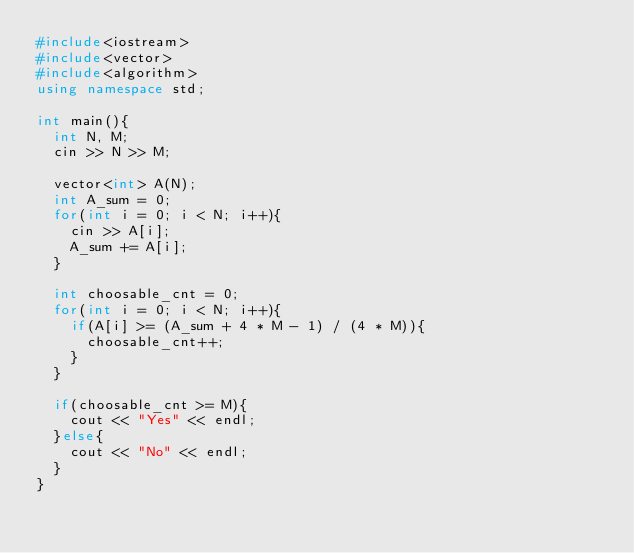<code> <loc_0><loc_0><loc_500><loc_500><_C++_>#include<iostream>
#include<vector>
#include<algorithm>
using namespace std;

int main(){
  int N, M;
  cin >> N >> M;

  vector<int> A(N);
  int A_sum = 0;
  for(int i = 0; i < N; i++){
    cin >> A[i];
    A_sum += A[i];
  }

  int choosable_cnt = 0;
  for(int i = 0; i < N; i++){
    if(A[i] >= (A_sum + 4 * M - 1) / (4 * M)){
      choosable_cnt++;
    }
  }

  if(choosable_cnt >= M){
    cout << "Yes" << endl;
  }else{
    cout << "No" << endl;
  }
}

</code> 